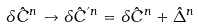Convert formula to latex. <formula><loc_0><loc_0><loc_500><loc_500>\delta \hat { C } ^ { n } \to \delta \hat { C } ^ { ^ { \prime } n } = \delta \hat { C } ^ { n } + \hat { \Delta } ^ { n }</formula> 